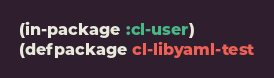<code> <loc_0><loc_0><loc_500><loc_500><_Lisp_>(in-package :cl-user)
(defpackage cl-libyaml-test</code> 